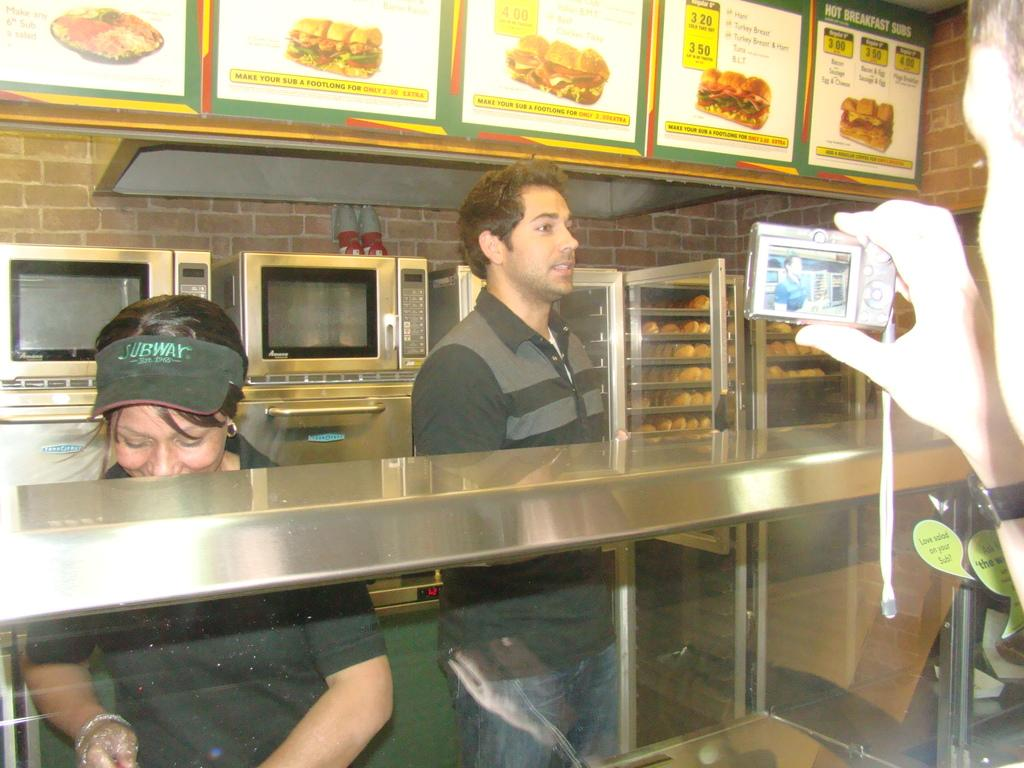<image>
Provide a brief description of the given image. a person taking a photo of SUBWAY workers behind a counter 